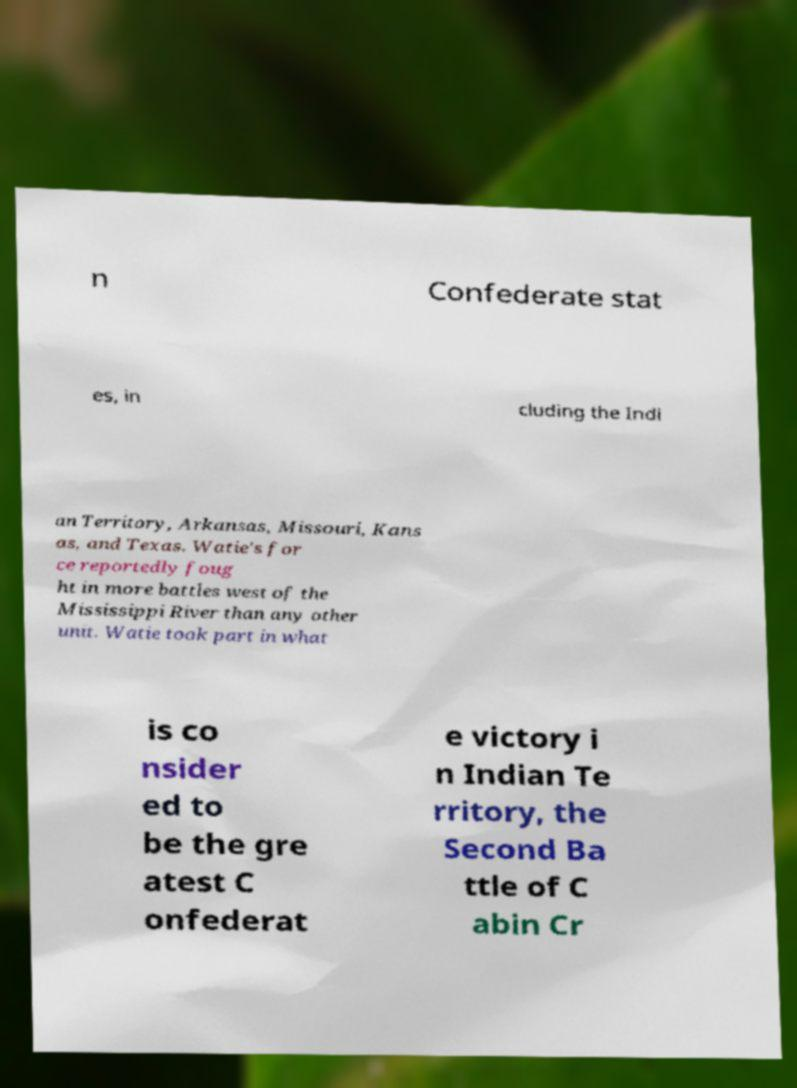Can you accurately transcribe the text from the provided image for me? n Confederate stat es, in cluding the Indi an Territory, Arkansas, Missouri, Kans as, and Texas. Watie's for ce reportedly foug ht in more battles west of the Mississippi River than any other unit. Watie took part in what is co nsider ed to be the gre atest C onfederat e victory i n Indian Te rritory, the Second Ba ttle of C abin Cr 